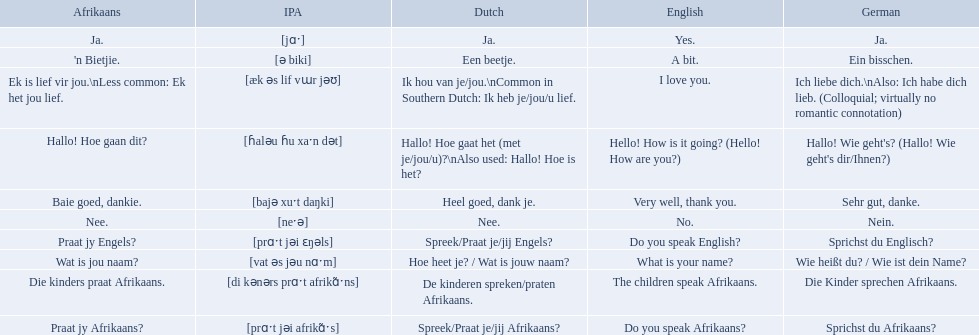What are the afrikaans phrases? Hallo! Hoe gaan dit?, Baie goed, dankie., Praat jy Afrikaans?, Praat jy Engels?, Ja., Nee., 'n Bietjie., Wat is jou naam?, Die kinders praat Afrikaans., Ek is lief vir jou.\nLess common: Ek het jou lief. For die kinders praat afrikaans, what are the translations? De kinderen spreken/praten Afrikaans., The children speak Afrikaans., Die Kinder sprechen Afrikaans. Which one is the german translation? Die Kinder sprechen Afrikaans. What are the listed afrikaans phrases? Hallo! Hoe gaan dit?, Baie goed, dankie., Praat jy Afrikaans?, Praat jy Engels?, Ja., Nee., 'n Bietjie., Wat is jou naam?, Die kinders praat Afrikaans., Ek is lief vir jou.\nLess common: Ek het jou lief. Which is die kinders praat afrikaans? Die kinders praat Afrikaans. What is its german translation? Die Kinder sprechen Afrikaans. In german how do you say do you speak afrikaans? Sprichst du Afrikaans?. How do you say it in afrikaans? Praat jy Afrikaans?. What are all of the afrikaans phrases shown in the table? Hallo! Hoe gaan dit?, Baie goed, dankie., Praat jy Afrikaans?, Praat jy Engels?, Ja., Nee., 'n Bietjie., Wat is jou naam?, Die kinders praat Afrikaans., Ek is lief vir jou.\nLess common: Ek het jou lief. Of those, which translates into english as do you speak afrikaans?? Praat jy Afrikaans?. 